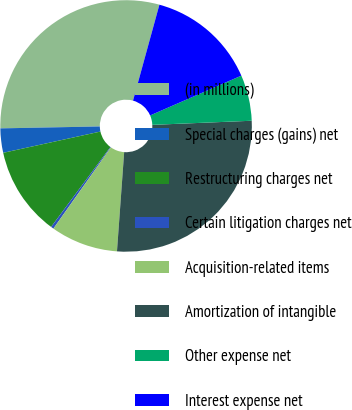Convert chart to OTSL. <chart><loc_0><loc_0><loc_500><loc_500><pie_chart><fcel>(in millions)<fcel>Special charges (gains) net<fcel>Restructuring charges net<fcel>Certain litigation charges net<fcel>Acquisition-related items<fcel>Amortization of intangible<fcel>Other expense net<fcel>Interest expense net<nl><fcel>29.58%<fcel>3.12%<fcel>11.41%<fcel>0.36%<fcel>8.65%<fcel>26.81%<fcel>5.89%<fcel>14.18%<nl></chart> 